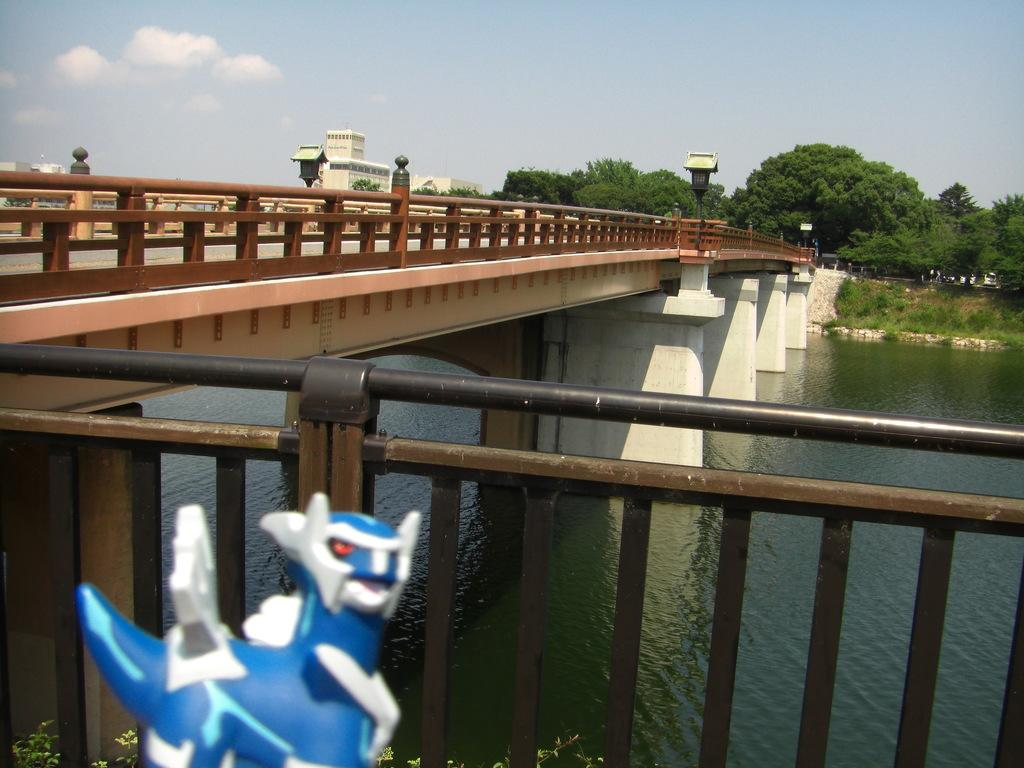What is above the water in the image? There is a bridge above the water in the image. What type of vegetation can be seen in the image? There are trees and plants in the image. What structures are present in the image? There are buildings in the image. What type of illumination is present in the image? There are lights in the image. What object is not meant for practical use in the image? There is a toy in the image. What part of the natural environment is visible in the background of the image? The sky is visible in the background of the image. Where is the alley located in the image? There is no alley present in the image. What type of vehicle is driving through the water in the image? There is no vehicle present in the image, let alone driving through the water. 